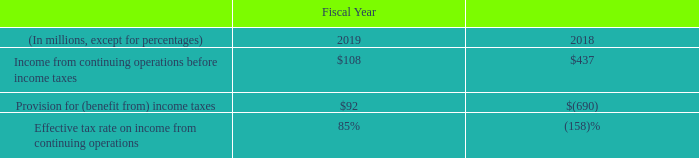Provision for income taxes
We are a U.S.-based multinational company subject to tax in multiple U.S. and international tax jurisdictions. A substantial portion of our international earnings were generated from subsidiaries organized in Ireland and Singapore. Our results of operations would be adversely affected to the extent that our geographical mix of income becomes more weighted toward jurisdictions with higher tax rates and would be favorably affected to the extent the relative geographic mix shifts to lower tax jurisdictions. Any change in our mix of earnings is dependent upon many factors and is therefore difficult to predict.
The increase in our effective tax rate in fiscal 2019 compared to fiscal 2018 was primarily due to one-time benefits from the 2017 Tax Act in fiscal 2018. In addition, increases in tax expense in fiscal 2019 are attributable to the valuation allowance on capital losses for which we cannot yet recognize a tax benefit.
What is the increase in effective tax rate in fiscal 2019 compared to fiscal 2018 primarily due to? One-time benefits from the 2017 tax act in fiscal 2018. What is the Income from continuing operations before income taxes for Fiscal 2018?
Answer scale should be: million. $437. What is the Income from continuing operations before income taxes for Fiscal 2019?
Answer scale should be: million. $108. What is the change in Income from continuing operations before income taxes from fiscal 2018 to fiscal 2019?
Answer scale should be: million. 437-108
Answer: 329. What is the average  Income from continuing operations before income taxes for fiscal 2019 and fiscal 2018?
Answer scale should be: million. (108+437)/2
Answer: 272.5. What is the average  Provision for (benefit from) income taxes?
Answer scale should be: million. (92+(-690))/2
Answer: -299. 